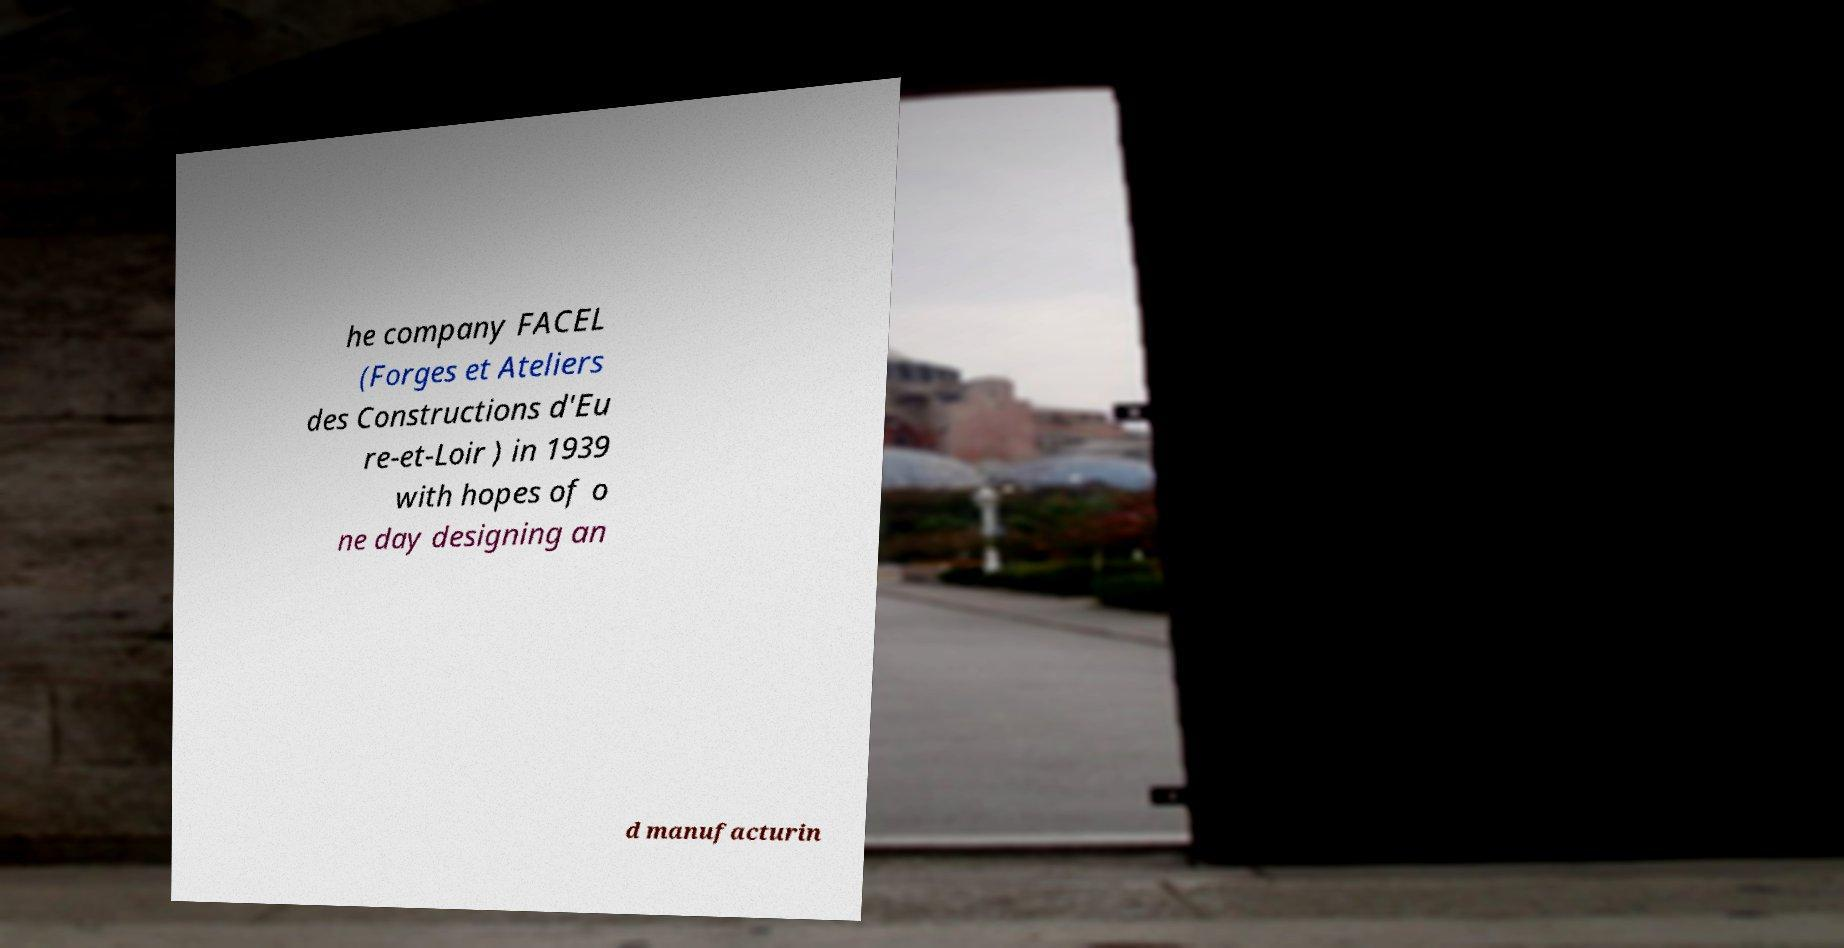Please identify and transcribe the text found in this image. he company FACEL (Forges et Ateliers des Constructions d'Eu re-et-Loir ) in 1939 with hopes of o ne day designing an d manufacturin 